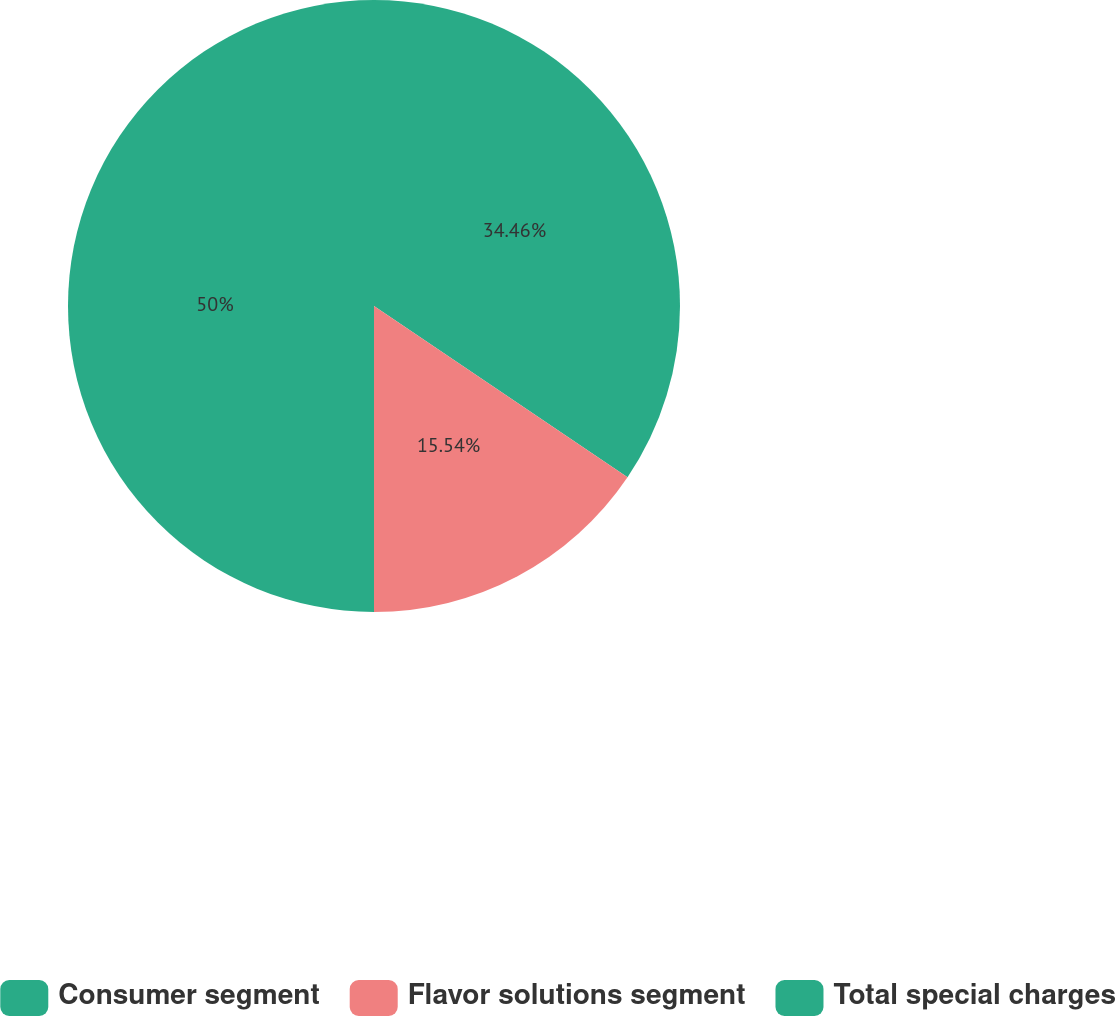Convert chart to OTSL. <chart><loc_0><loc_0><loc_500><loc_500><pie_chart><fcel>Consumer segment<fcel>Flavor solutions segment<fcel>Total special charges<nl><fcel>34.46%<fcel>15.54%<fcel>50.0%<nl></chart> 